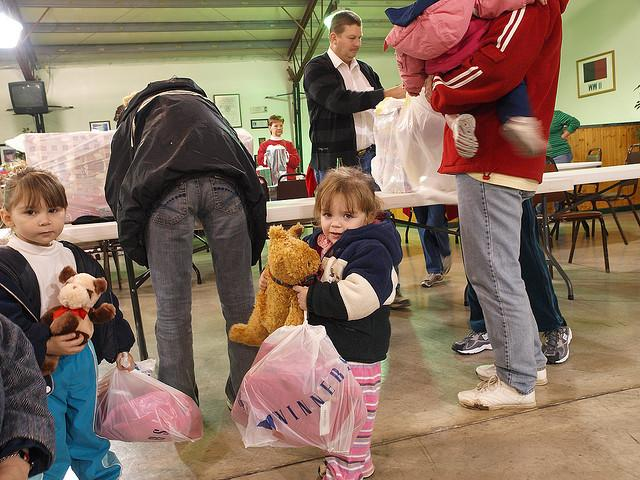What are the two girls in front doing? Please explain your reasoning. waiting. The two little girls are standing while the adults in the background are engaging with other adults. 